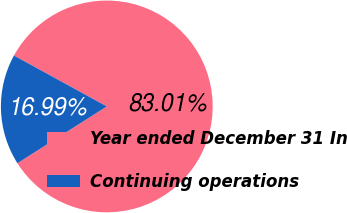<chart> <loc_0><loc_0><loc_500><loc_500><pie_chart><fcel>Year ended December 31 In<fcel>Continuing operations<nl><fcel>83.01%<fcel>16.99%<nl></chart> 